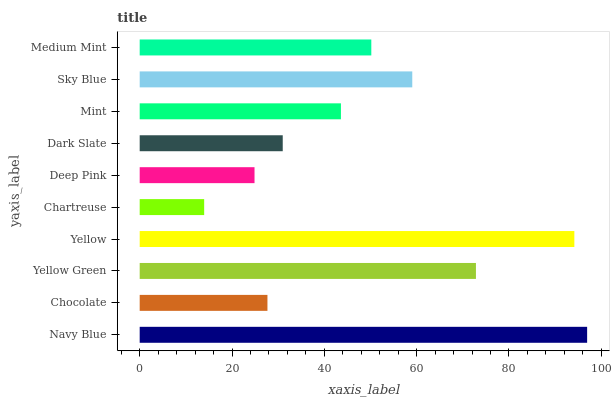Is Chartreuse the minimum?
Answer yes or no. Yes. Is Navy Blue the maximum?
Answer yes or no. Yes. Is Chocolate the minimum?
Answer yes or no. No. Is Chocolate the maximum?
Answer yes or no. No. Is Navy Blue greater than Chocolate?
Answer yes or no. Yes. Is Chocolate less than Navy Blue?
Answer yes or no. Yes. Is Chocolate greater than Navy Blue?
Answer yes or no. No. Is Navy Blue less than Chocolate?
Answer yes or no. No. Is Medium Mint the high median?
Answer yes or no. Yes. Is Mint the low median?
Answer yes or no. Yes. Is Dark Slate the high median?
Answer yes or no. No. Is Deep Pink the low median?
Answer yes or no. No. 